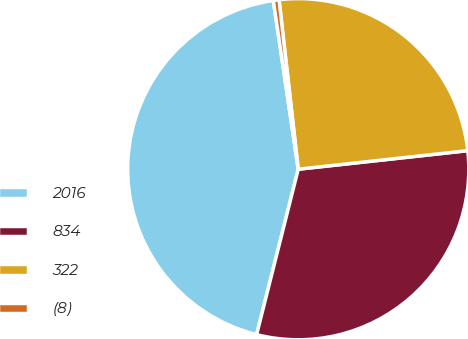Convert chart. <chart><loc_0><loc_0><loc_500><loc_500><pie_chart><fcel>2016<fcel>834<fcel>322<fcel>(8)<nl><fcel>43.74%<fcel>30.66%<fcel>25.06%<fcel>0.54%<nl></chart> 